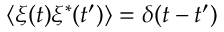Convert formula to latex. <formula><loc_0><loc_0><loc_500><loc_500>\langle \xi ( t ) \xi ^ { * } ( t ^ { \prime } ) \rangle = \delta ( t - t ^ { \prime } )</formula> 